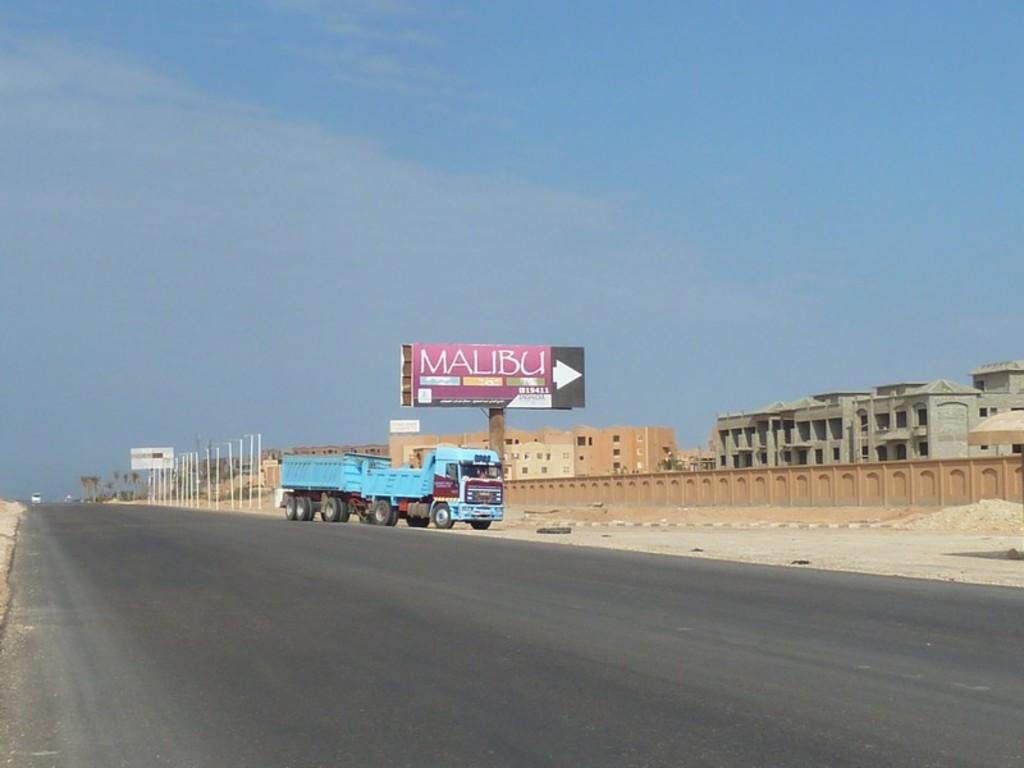<image>
Present a compact description of the photo's key features. A blue truck is parked right outside a center called Malibu 